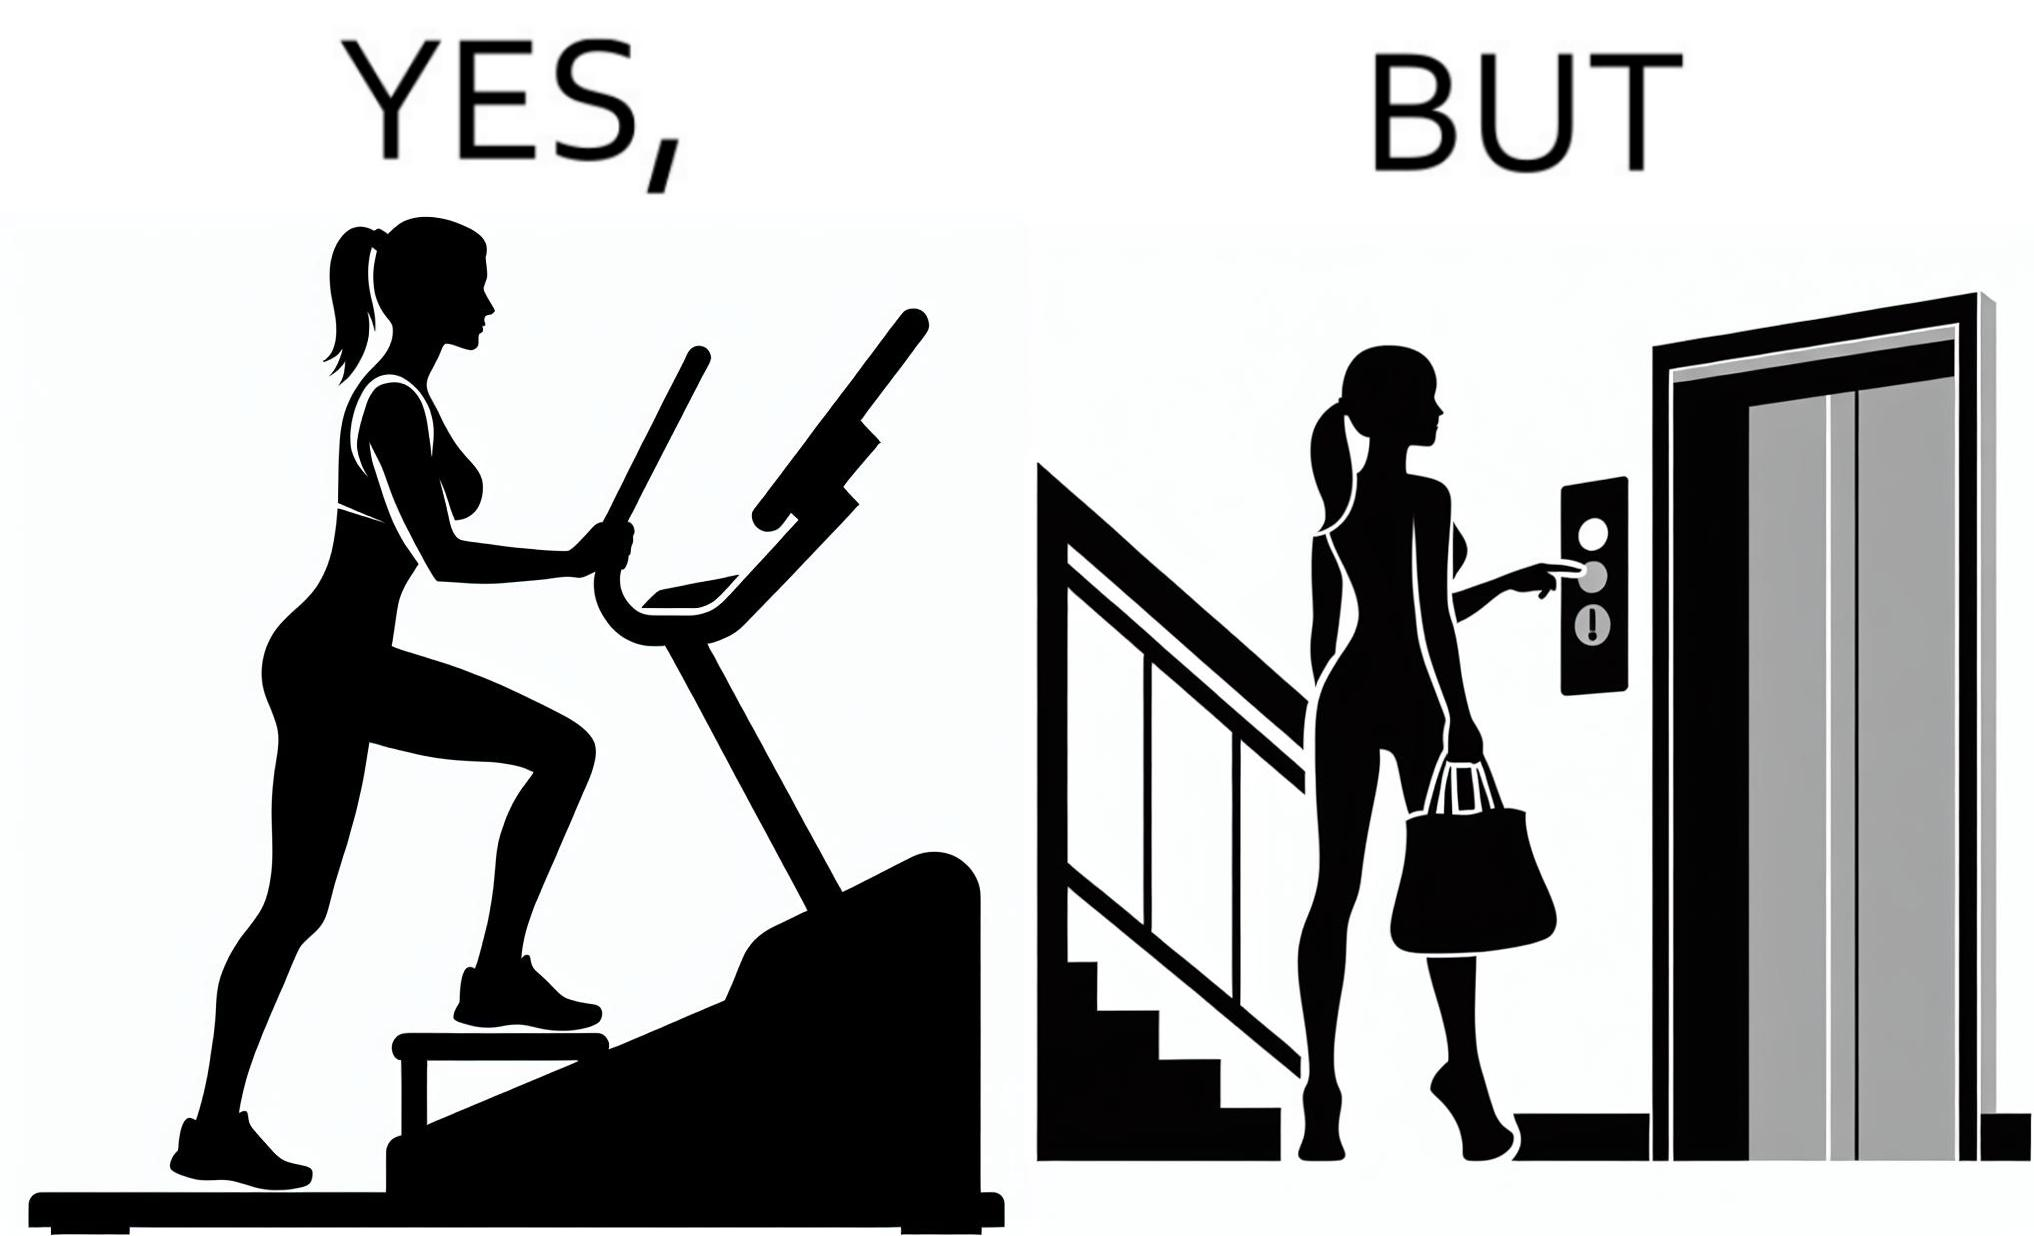Does this image contain satire or humor? Yes, this image is satirical. 